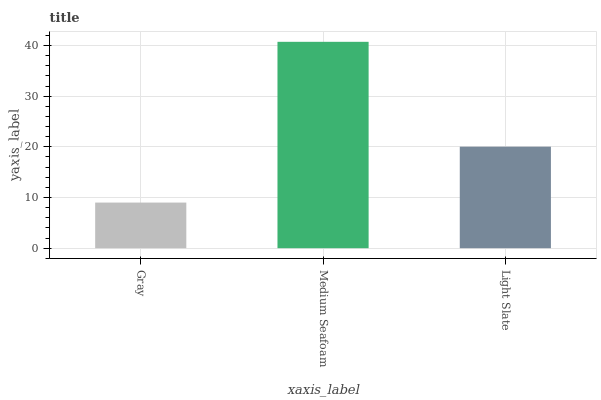Is Light Slate the minimum?
Answer yes or no. No. Is Light Slate the maximum?
Answer yes or no. No. Is Medium Seafoam greater than Light Slate?
Answer yes or no. Yes. Is Light Slate less than Medium Seafoam?
Answer yes or no. Yes. Is Light Slate greater than Medium Seafoam?
Answer yes or no. No. Is Medium Seafoam less than Light Slate?
Answer yes or no. No. Is Light Slate the high median?
Answer yes or no. Yes. Is Light Slate the low median?
Answer yes or no. Yes. Is Medium Seafoam the high median?
Answer yes or no. No. Is Medium Seafoam the low median?
Answer yes or no. No. 